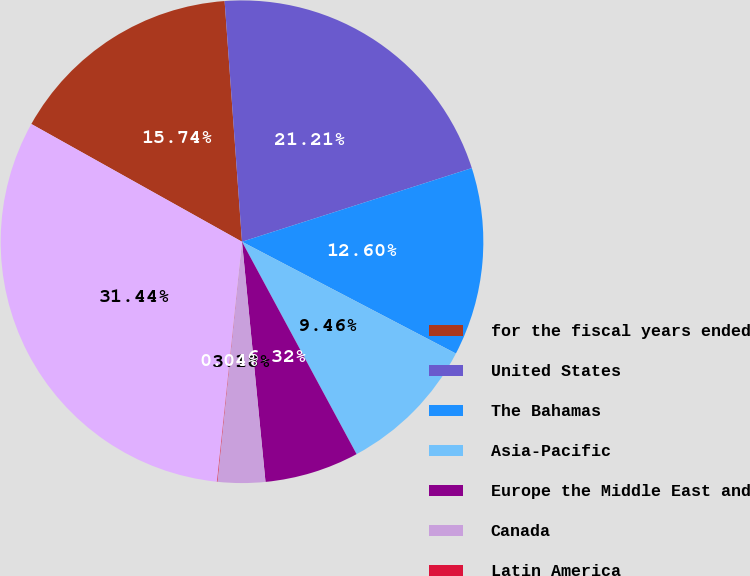Convert chart. <chart><loc_0><loc_0><loc_500><loc_500><pie_chart><fcel>for the fiscal years ended<fcel>United States<fcel>The Bahamas<fcel>Asia-Pacific<fcel>Europe the Middle East and<fcel>Canada<fcel>Latin America<fcel>Total<nl><fcel>15.74%<fcel>21.21%<fcel>12.6%<fcel>9.46%<fcel>6.32%<fcel>3.18%<fcel>0.04%<fcel>31.44%<nl></chart> 